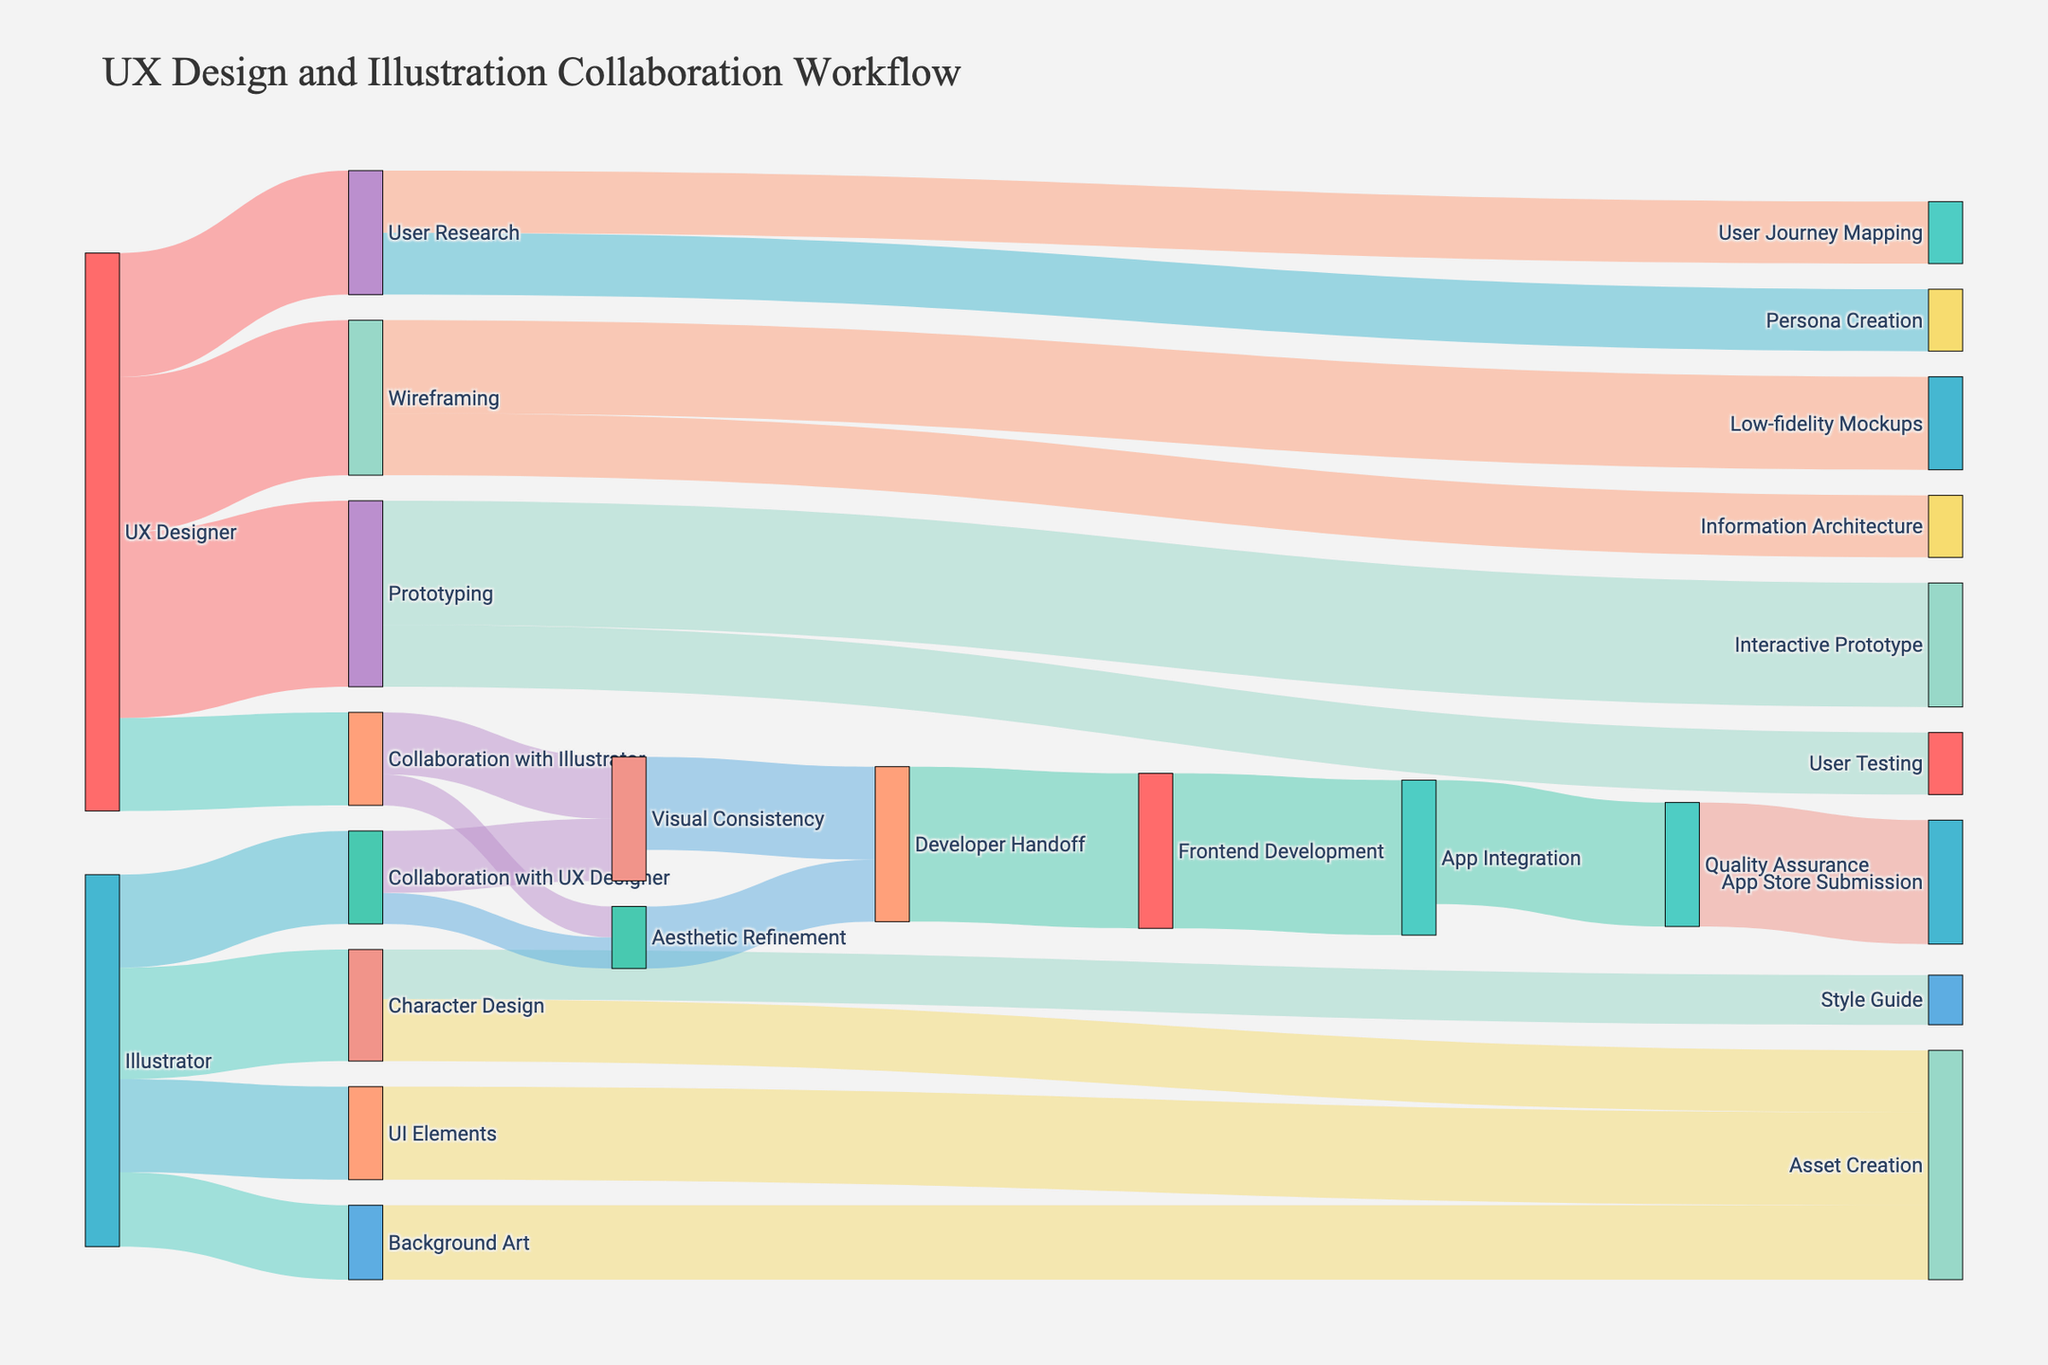What is the title of the diagram? The title of the diagram is typically displayed prominently at the top of the figure. By looking at the figure, one can see that the title is "UX Design and Illustration Collaboration Workflow".
Answer: UX Design and Illustration Collaboration Workflow What are the main roles shown in the diagram? The main roles are the starting nodes in the Sankey diagram. By examining the source nodes, we identify "UX Designer," "Illustrator," and "Developer" as the key roles involved in the workflow.
Answer: UX Designer, Illustrator, Developer Which processes involve collaboration between a UX Designer and an Illustrator? In the figure, we can look at the flows where the source or target mentions collaboration. The processes include "Collaboration with Illustrator" and "Collaboration with UX Designer".
Answer: Collaboration with Illustrator, Collaboration with UX Designer What is the combined value of processes under Wireframing? To find the combined value, sum the values of processes that have Wireframing as a source: Low-fidelity Mockups (15) and Information Architecture (10). The combined value is 15+10.
Answer: 25 Which task follows after "Visual Consistency" with the smallest value? Investigating the flows that originate from "Visual Consistency," the subsequent tasks are "Developer Handoff" (15). As it's the only flow from "Visual Consistency," it is also the smallest.
Answer: Developer Handoff How do User Research related tasks divide their values? User Research is connected to Persona Creation (10) and User Journey Mapping (10). Each task receives an equal value of 10.
Answer: Persona Creation: 10, User Journey Mapping: 10 What is the difference in values between "Prototyping" and "Wireframing" outcomes? Sum the outcomes of "Prototyping" (Interactive Prototype: 20, User Testing: 10, total = 30) and "Wireframing" (Low-fidelity Mockups: 15, Information Architecture: 10, total = 25). Then, subtract the totals (30 - 25).
Answer: 5 Which process under the Illustrator role has the highest value and what is the value? By examining the connections under the Illustrator role: Character Design (18), Background Art (12), UI Elements (15), the process with the highest value is Character Design (18).
Answer: Character Design: 18 What is the total value flowing into Frontend Development? Frontend Development receives values from Developer Handoff. By locating the incoming flow, Developer Handoff has a value of 25 flowing into Frontend Development.
Answer: 25 How does the flow from "App Integration" distribute its values? Looking at flows out of App Integration, it distributes values to Quality Assurance (20). App Store Submission follows Quality Assurance but is not directly from App Integration.
Answer: Quality Assurance: 20 